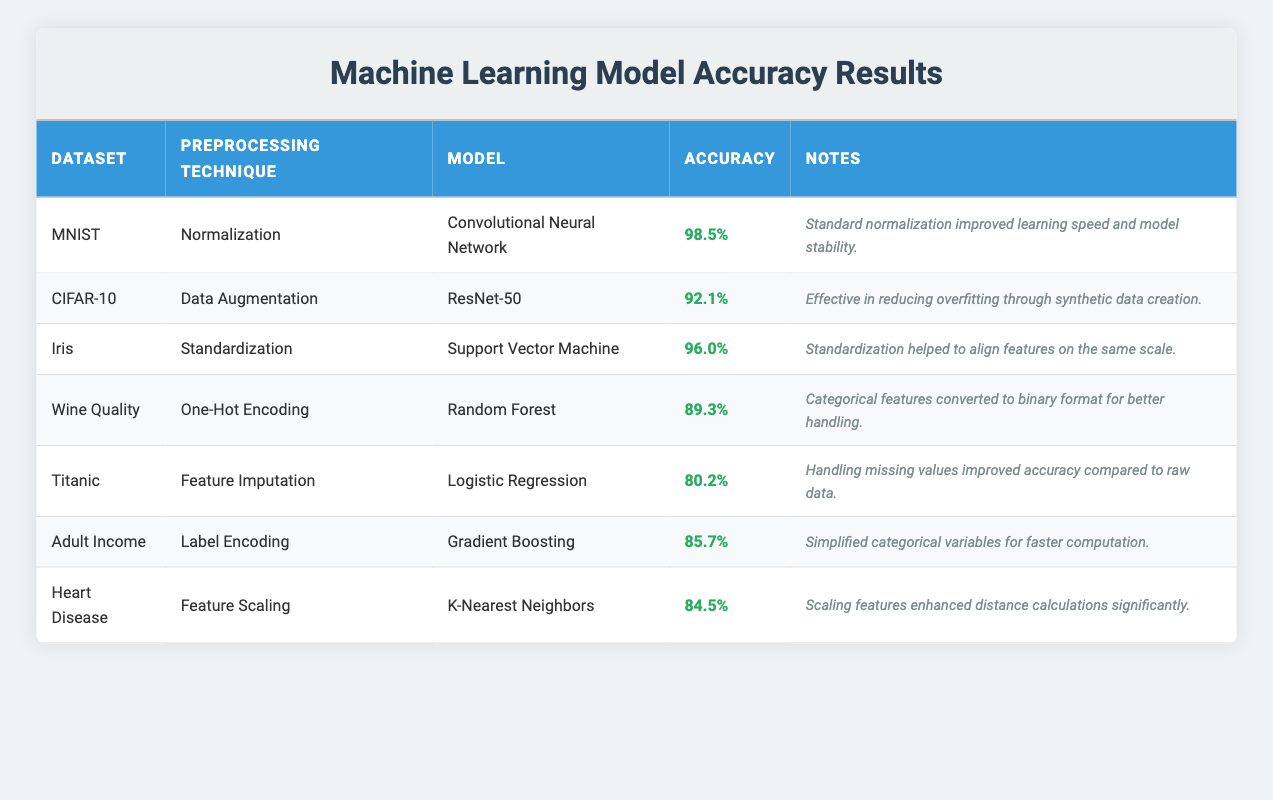What is the accuracy of the Convolutional Neural Network on the MNIST dataset? The accuracy is explicitly listed in the MNIST row of the table under the Accuracy column, showing a value of 98.5%.
Answer: 98.5% Which preprocessing technique is used for the Random Forest model on the Wine Quality dataset? By referring to the Wine Quality row in the table, we can see that the preprocessing technique listed is One-Hot Encoding.
Answer: One-Hot Encoding How does the accuracy of the Gradient Boosting model on the Adult Income dataset compare to the Logistic Regression model on the Titanic dataset? The Gradient Boosting model has an accuracy of 85.7%, while the Logistic Regression model has an accuracy of 80.2%. Thus, Gradient Boosting is more accurate by a difference of 5.5%.
Answer: Gradient Boosting is 5.5% more accurate Is the accuracy of K-Nearest Neighbors on the Heart Disease dataset higher than that of the Random Forest on the Wine Quality dataset? The accuracy of K-Nearest Neighbors on the Heart Disease dataset is 84.5%, which is lower than the Random Forest model's accuracy of 89.3%. Hence, the statement is false.
Answer: No What preprocessing technique has the highest accuracy, and what is that accuracy? We need to check each row to determine which has the highest accuracy, finding that Normalization used with the Convolutional Neural Network on MNIST shows the highest accuracy at 98.5%.
Answer: Normalization, 98.5% Which model had the lowest recorded accuracy and what was that accuracy? To find this, we compare the accuracy values listed in the last column. The Logistic Regression model on the Titanic dataset shows the lowest accuracy of 80.2%.
Answer: Logistic Regression, 80.2% What is the average accuracy of the models that use data augmentation as a preprocessing technique? The only model that uses data augmentation is the ResNet-50 model on the CIFAR-10 dataset, which has an accuracy of 92.1%. Since there is only one model, the average is simply that accuracy.
Answer: 92.1% Do all models exhibit an accuracy greater than 80%? By examining the accuracies in the table, we see that all models, including Logistic Regression at 80.2%, confirm that each of them exceeds or meets 80%. Thus, the answer is yes.
Answer: Yes 